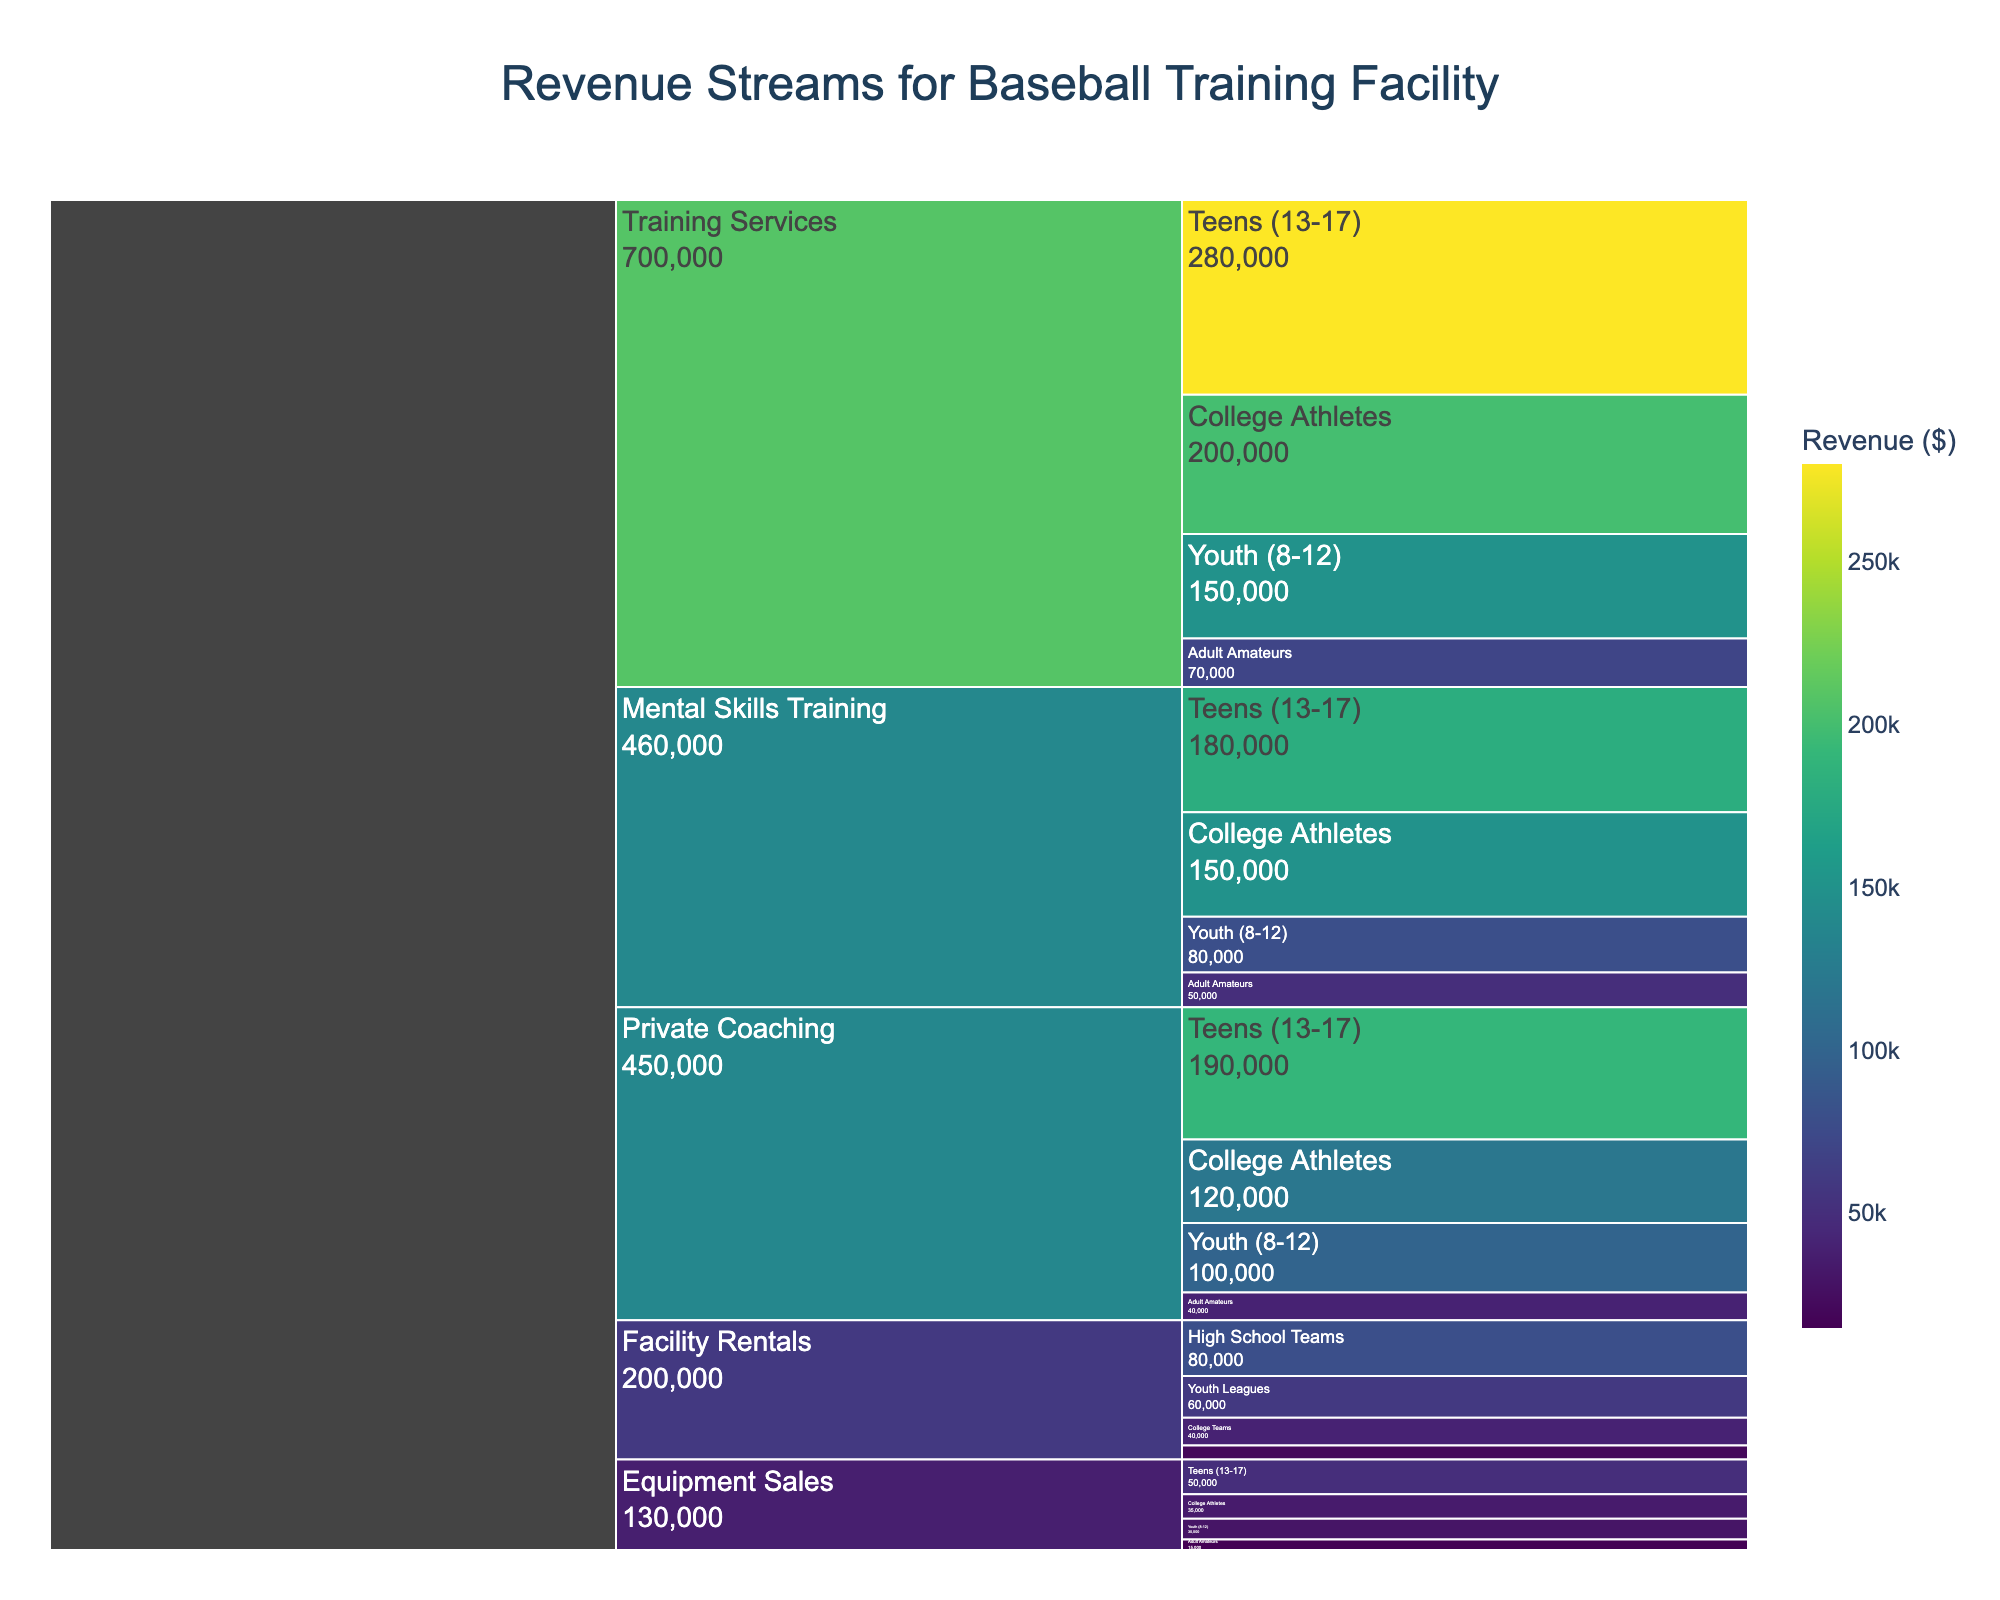What is the title of the Icicle chart? The title is usually located at the top of the chart and provides a brief description of what the chart illustrates.
Answer: Revenue Streams for Baseball Training Facility Which service type generates the most revenue overall? Looking at the Icicle chart, identify the largest segment under the primary category "Service Type" to see which generates the most revenue.
Answer: Training Services Under "Mental Skills Training," which client demographic brings in the highest revenue? Navigate within the "Mental Skills Training" section of the Icicle chart and compare the revenue values of different client demographics to find the highest one.
Answer: Teens (13-17) What is the total revenue generated from "Private Coaching"? Sum the revenues from each client demographic under the "Private Coaching" section: 100,000 (Youth) + 190,000 (Teens) + 120,000 (College Athletes) + 40,000 (Adult Amateurs).
Answer: 450,000 Among "Equipment Sales" for all client demographics, which one contributes the least revenue? Inspect the "Equipment Sales" section and compare the revenue values for each demographic to find the smallest one.
Answer: Adult Amateurs How does the revenue from "Training Services" for "Teens (13-17)" compare to the revenue from "Mental Skills Training" for the same demographic? Locate the revenue values for "Teens (13-17)" under both "Training Services" and "Mental Skills Training" and compare them: 280,000 vs. 180,000.
Answer: Training Services generates more for Teens (13-17) What is the total revenue from "Facility Rentals"? Sum the revenues from each client demographic under the "Facility Rentals" section: 60,000 (Youth Leagues) + 80,000 (High School Teams) + 40,000 (College Teams) + 20,000 (Adult Leagues).
Answer: 200,000 Which client demographic generates the most revenue for "Private Coaching"? Navigate within the "Private Coaching" section of the Icicle chart and compare the revenue values of different client demographics to find the highest one.
Answer: Teens (13-17) Among all service types, which client demographic brings in the highest single revenue? Examine the chart to find the highest revenue value among all client demographics in all service types.
Answer: Teens (13-17) for Training Services How does the total revenue from "Adult Amateurs" compare to the total revenue from "Youth (8-12)" across all service types? Sum the revenues for "Adult Amateurs" and for "Youth (8-12)" from each service type and compare the totals: (70,000 + 50,000 + 40,000 + 15,000) vs. (150,000 + 80,000 + 100,000 + 30,000).
Answer: Youth (8-12) generates more revenue 